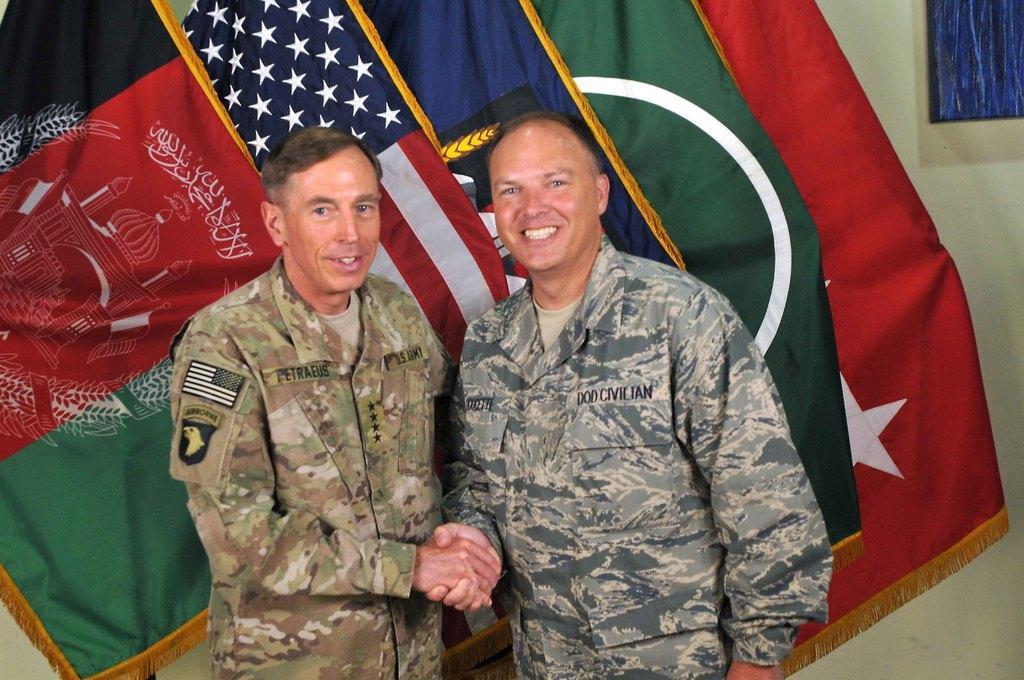Could you give a brief overview of what you see in this image? In this image, there are two people standing. We can also see some flags. We can see the wall with a blue colored object. 